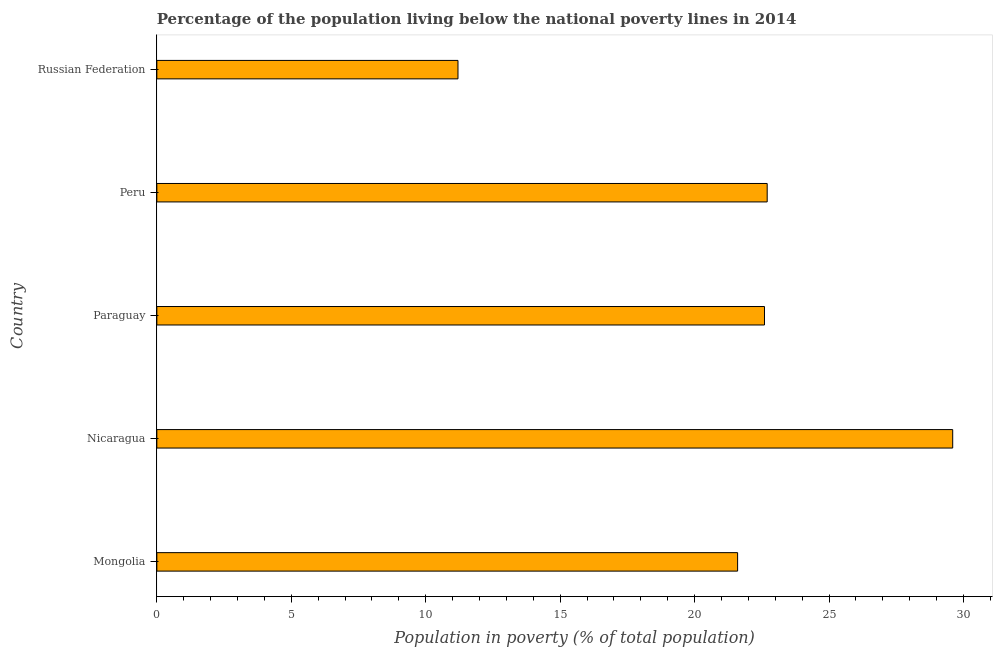Does the graph contain grids?
Your answer should be very brief. No. What is the title of the graph?
Give a very brief answer. Percentage of the population living below the national poverty lines in 2014. What is the label or title of the X-axis?
Make the answer very short. Population in poverty (% of total population). What is the label or title of the Y-axis?
Your answer should be compact. Country. Across all countries, what is the maximum percentage of population living below poverty line?
Make the answer very short. 29.6. In which country was the percentage of population living below poverty line maximum?
Your answer should be compact. Nicaragua. In which country was the percentage of population living below poverty line minimum?
Your answer should be very brief. Russian Federation. What is the sum of the percentage of population living below poverty line?
Make the answer very short. 107.7. What is the average percentage of population living below poverty line per country?
Ensure brevity in your answer.  21.54. What is the median percentage of population living below poverty line?
Offer a very short reply. 22.6. In how many countries, is the percentage of population living below poverty line greater than 9 %?
Provide a succinct answer. 5. What is the ratio of the percentage of population living below poverty line in Mongolia to that in Russian Federation?
Give a very brief answer. 1.93. Is the percentage of population living below poverty line in Nicaragua less than that in Peru?
Your answer should be very brief. No. Is the difference between the percentage of population living below poverty line in Nicaragua and Paraguay greater than the difference between any two countries?
Provide a short and direct response. No. In how many countries, is the percentage of population living below poverty line greater than the average percentage of population living below poverty line taken over all countries?
Ensure brevity in your answer.  4. How many bars are there?
Provide a short and direct response. 5. How many countries are there in the graph?
Provide a succinct answer. 5. What is the Population in poverty (% of total population) of Mongolia?
Your answer should be very brief. 21.6. What is the Population in poverty (% of total population) of Nicaragua?
Offer a very short reply. 29.6. What is the Population in poverty (% of total population) in Paraguay?
Provide a short and direct response. 22.6. What is the Population in poverty (% of total population) in Peru?
Your answer should be very brief. 22.7. What is the Population in poverty (% of total population) in Russian Federation?
Provide a succinct answer. 11.2. What is the difference between the Population in poverty (% of total population) in Mongolia and Paraguay?
Make the answer very short. -1. What is the difference between the Population in poverty (% of total population) in Nicaragua and Paraguay?
Make the answer very short. 7. What is the difference between the Population in poverty (% of total population) in Nicaragua and Peru?
Make the answer very short. 6.9. What is the difference between the Population in poverty (% of total population) in Nicaragua and Russian Federation?
Your response must be concise. 18.4. What is the difference between the Population in poverty (% of total population) in Paraguay and Russian Federation?
Make the answer very short. 11.4. What is the ratio of the Population in poverty (% of total population) in Mongolia to that in Nicaragua?
Your answer should be very brief. 0.73. What is the ratio of the Population in poverty (% of total population) in Mongolia to that in Paraguay?
Provide a short and direct response. 0.96. What is the ratio of the Population in poverty (% of total population) in Mongolia to that in Peru?
Give a very brief answer. 0.95. What is the ratio of the Population in poverty (% of total population) in Mongolia to that in Russian Federation?
Keep it short and to the point. 1.93. What is the ratio of the Population in poverty (% of total population) in Nicaragua to that in Paraguay?
Your answer should be compact. 1.31. What is the ratio of the Population in poverty (% of total population) in Nicaragua to that in Peru?
Offer a very short reply. 1.3. What is the ratio of the Population in poverty (% of total population) in Nicaragua to that in Russian Federation?
Provide a succinct answer. 2.64. What is the ratio of the Population in poverty (% of total population) in Paraguay to that in Peru?
Provide a short and direct response. 1. What is the ratio of the Population in poverty (% of total population) in Paraguay to that in Russian Federation?
Ensure brevity in your answer.  2.02. What is the ratio of the Population in poverty (% of total population) in Peru to that in Russian Federation?
Offer a very short reply. 2.03. 